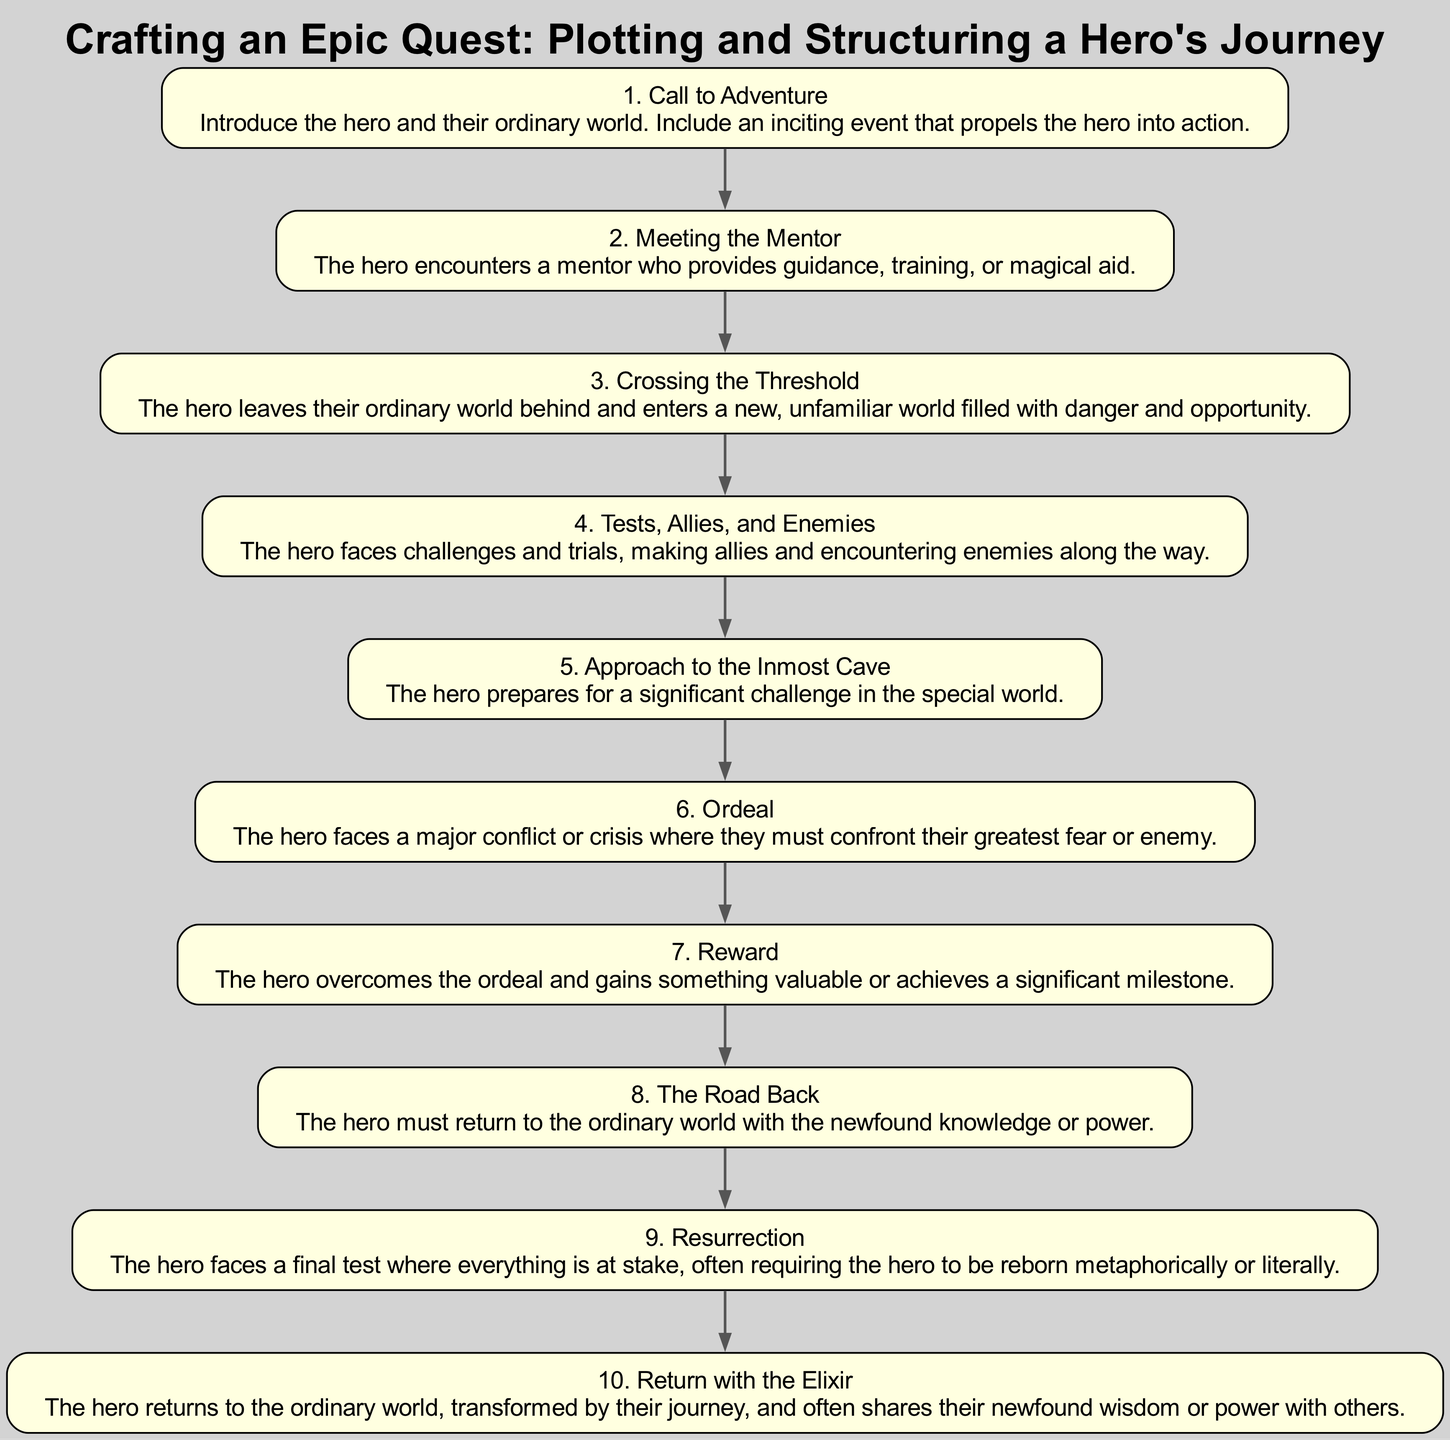What is the first step in the hero's journey? The first step listed in the diagram is "Call to Adventure." This step sets the stage by introducing the hero and their ordinary world before presenting an inciting event that propels them into action.
Answer: Call to Adventure How many total steps are there in the diagram? The diagram lists ten distinct steps, each representing a crucial part of the hero's journey. This is determined by counting the number of nodes present in the flowchart.
Answer: 10 What follows "Tests, Allies, and Enemies"? According to the flow of the diagram, "Approach to the Inmost Cave" directly follows "Tests, Allies, and Enemies." This is observed as the sequence of the steps increases by one from tests to approach.
Answer: Approach to the Inmost Cave Which step corresponds to the hero's final test? The "Resurrection" step corresponds to the hero's final test where everything is at stake, requiring the hero to undergo a significant transformation or challenge.
Answer: Resurrection Which examples illustrate the "Ordeal" step? The examples illustrating the "Ordeal" step are "Luke battling Darth Vader" and "Frodo confronted by Shelob," clearly mentioned under the description of this step in the diagram.
Answer: Luke battling Darth Vader, Frodo confronted by Shelob What step comes before "Return with the Elixir"? The step "Resurrection" comes immediately before "Return with the Elixir." This is verified by tracing the connections between the nodes in the flow, leading from resurrection to return.
Answer: Resurrection How many examples are provided for the "Meeting the Mentor" step? There are two examples provided for the "Meeting the Mentor" step: "Obi-Wan Kenobi guiding Luke Skywalker" and "Gandalf advising Frodo Baggins." This is determined by reviewing the examples listed under that specific step.
Answer: 2 What is the primary focus of the "Reward" step? The "Reward" step focuses on the hero overcoming an ordeal and gaining something valuable or achieving a significant milestone in their journey, as emphasized in its description.
Answer: Overcoming an ordeal Which step involves the hero leaving their familiar world? The step "Crossing the Threshold" involves the hero leaving their ordinary world and entering a new, unfamiliar world filled with danger and opportunity, as stated in the description of that step.
Answer: Crossing the Threshold What does the hero share upon completing their journey? Upon completing their journey, the hero shares their newfound wisdom or power with others, which is the essence of the "Return with the Elixir" step. This is derived from the explanation of what happens at that stage in the journey.
Answer: Newfound wisdom or power 